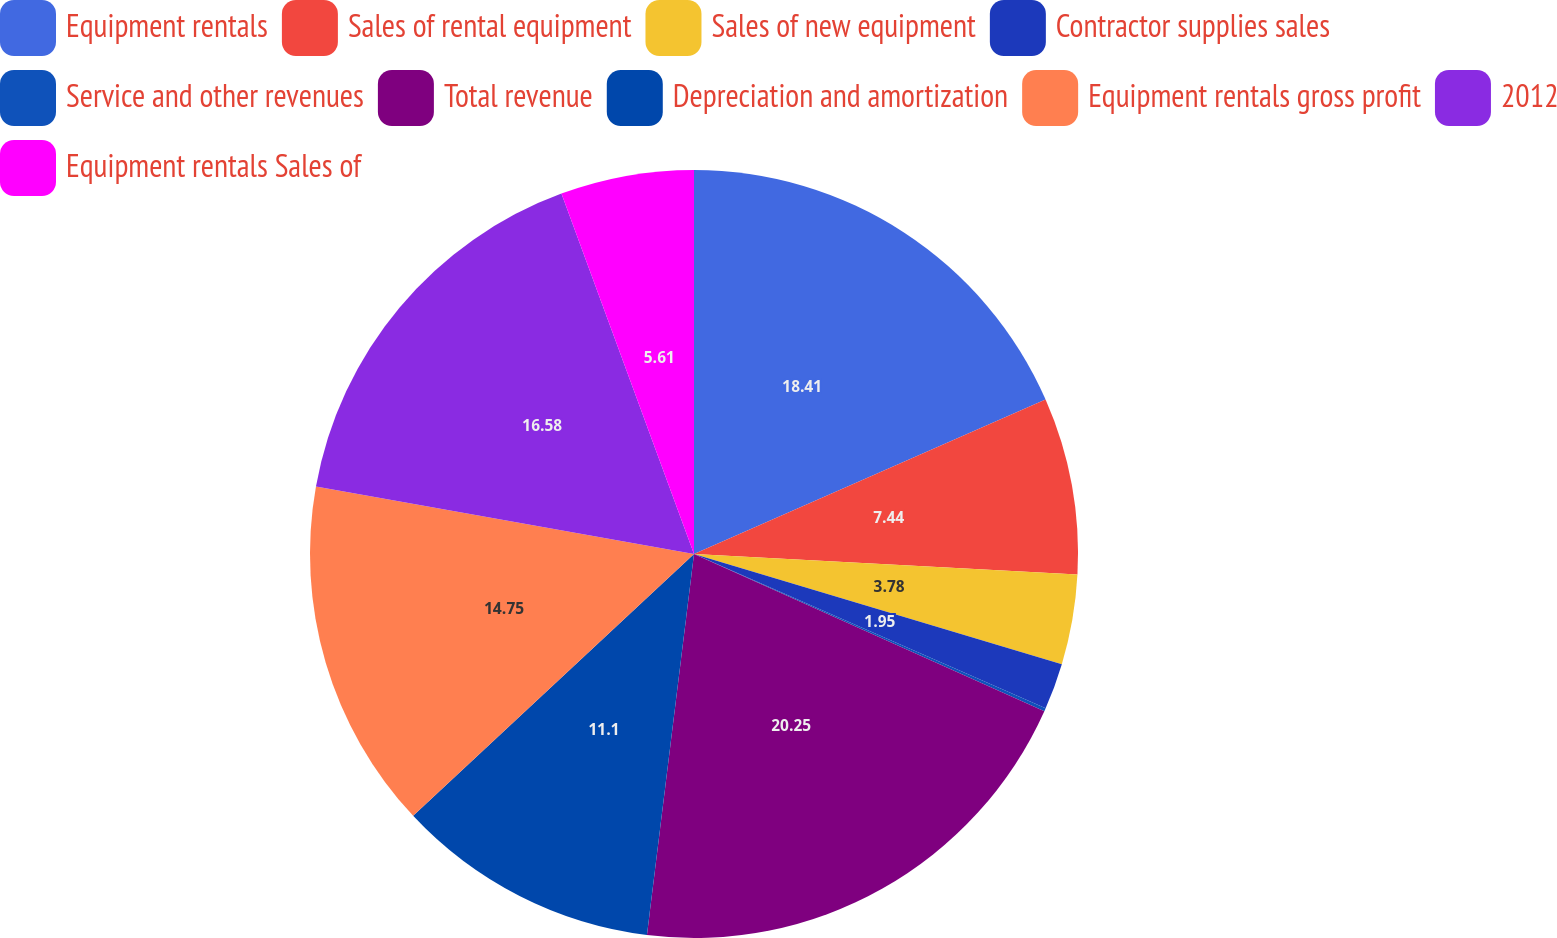<chart> <loc_0><loc_0><loc_500><loc_500><pie_chart><fcel>Equipment rentals<fcel>Sales of rental equipment<fcel>Sales of new equipment<fcel>Contractor supplies sales<fcel>Service and other revenues<fcel>Total revenue<fcel>Depreciation and amortization<fcel>Equipment rentals gross profit<fcel>2012<fcel>Equipment rentals Sales of<nl><fcel>18.41%<fcel>7.44%<fcel>3.78%<fcel>1.95%<fcel>0.13%<fcel>20.24%<fcel>11.1%<fcel>14.75%<fcel>16.58%<fcel>5.61%<nl></chart> 